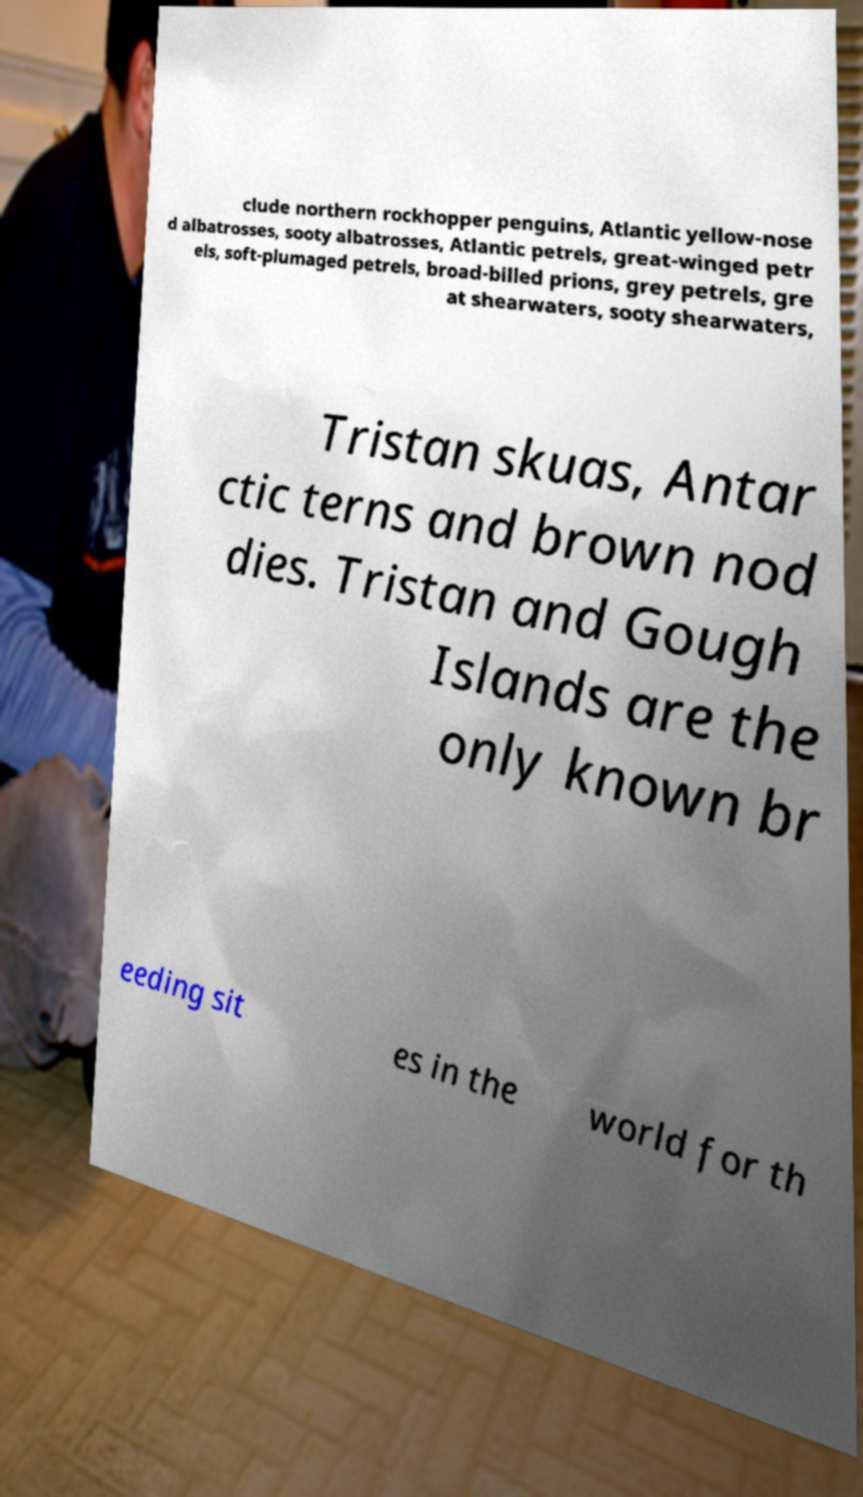Can you accurately transcribe the text from the provided image for me? clude northern rockhopper penguins, Atlantic yellow-nose d albatrosses, sooty albatrosses, Atlantic petrels, great-winged petr els, soft-plumaged petrels, broad-billed prions, grey petrels, gre at shearwaters, sooty shearwaters, Tristan skuas, Antar ctic terns and brown nod dies. Tristan and Gough Islands are the only known br eeding sit es in the world for th 